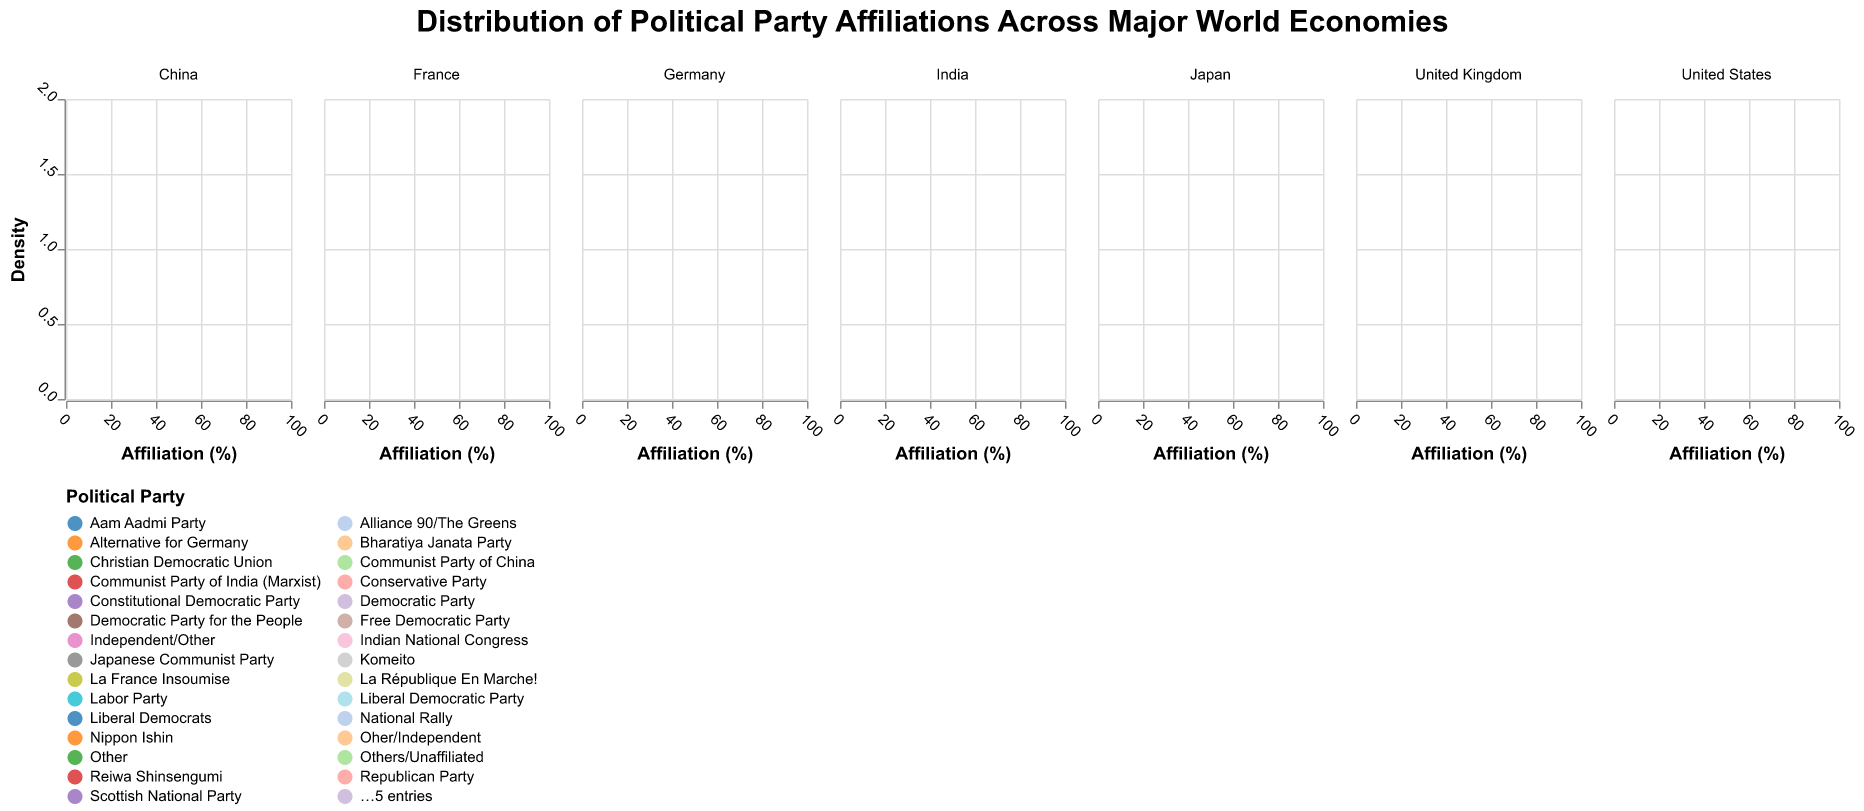What does the title of the figure say? The title is located at the top of the figure, and it provides an overview of what the plot represents.
Answer: "Distribution of Political Party Affiliations Across Major World Economies" Which country's data includes the highest single party affiliation? To determine this, look at the densities and the values on the x-axis. The country with a party having the highest number on the x-axis represents this. In this figure, "China" has "Communist Party of China" with an affiliation of 93%.
Answer: China Which country shows the most equal distribution among its political parties? Analyze the density plots for each country. The one with the closest densities among various parties indicates a more equal distribution.
Answer: United Kingdom How does the political party distribution in the United States compare to that in Germany? Look at the density plots for both countries. The United States has two major parties (Democratic and Republican) with more significant density peaks compared to the multiple parties with lower densities in Germany.
Answer: The United States has higher densities for two major parties, while Germany has a more spread-out distribution among multiple parties What is the color representation of the Bharatiya Janata Party in India? Check the legend at the bottom which shows the political parties and their corresponding colors.
Answer: Orange Which country appears to have the highest affiliation percentage for a single 'Other' or unaffiliated category? Identify the density plot with the 'Other' category, and compare the values on the x-axis to find the highest percentage. Both Japan and India have prominent 'Other' categories.
Answer: India (32%) and Japan (26%) What is the affiliation percentage of the Socialist Party in France? Identify the density plot for France and locate the 'Socialist Party' on the x-axis.
Answer: 6% Among the six countries, which has the smallest number of parties shown in the density plot? Count the number of distinct color regions in the density plot for each country. China has two (Communist Party of China and Others/Unaffiliated).
Answer: China How does the distribution of political party affiliations in India compare to that in the United States in terms of major parties' dominance? Analyze the density plots focusing on the largest peaks for both countries. India has Bharatiya Janata Party and the 'Other' category as dominant, while the United States has the Democratic and Republican parties as dominant.
Answer: Both have two dominant categories but different party configurations Which party in the United Kingdom has the smallest affiliation percentage, and what is the percentage? Locate the density plot for the United Kingdom and find the smallest peak on the x-axis corresponding to a named party.
Answer: The Green Party (3%) 